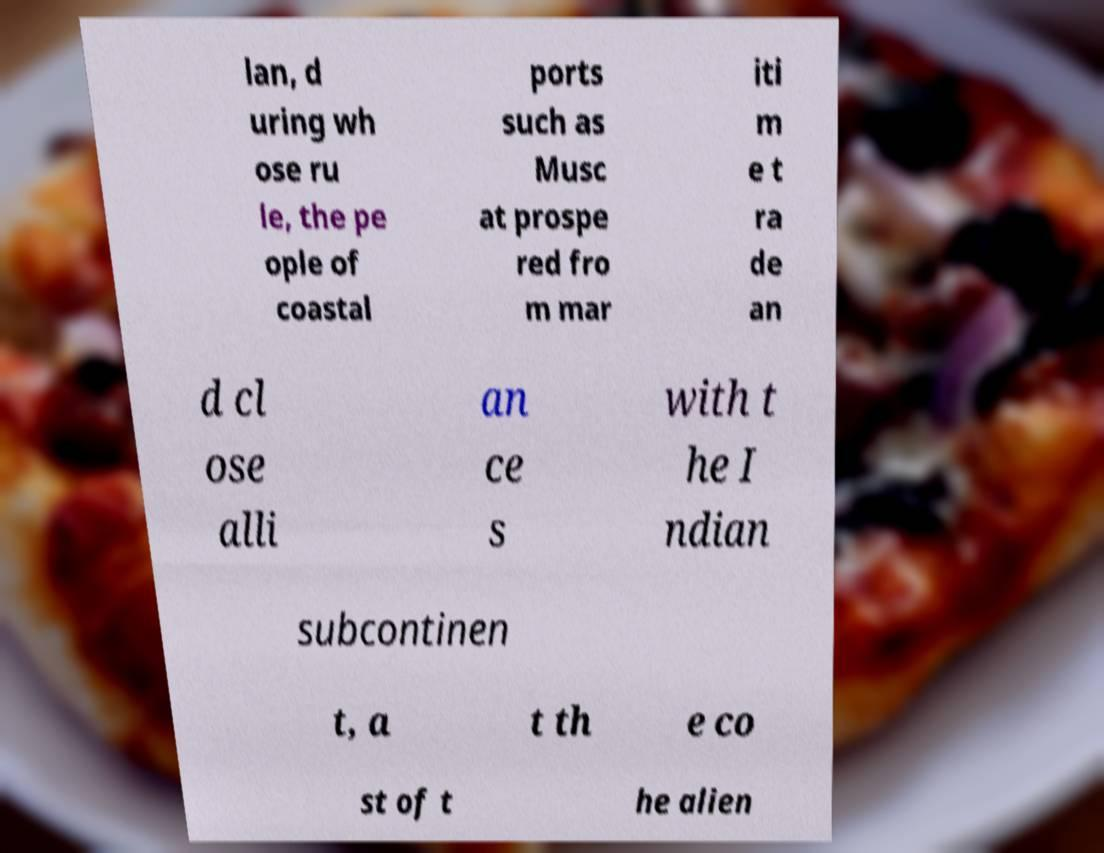Can you accurately transcribe the text from the provided image for me? lan, d uring wh ose ru le, the pe ople of coastal ports such as Musc at prospe red fro m mar iti m e t ra de an d cl ose alli an ce s with t he I ndian subcontinen t, a t th e co st of t he alien 